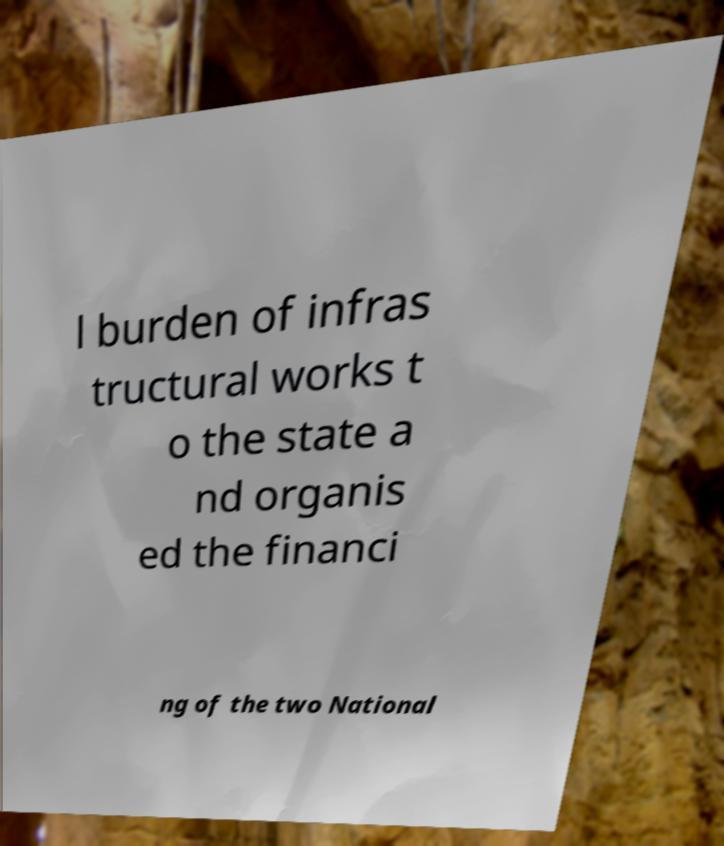Could you extract and type out the text from this image? l burden of infras tructural works t o the state a nd organis ed the financi ng of the two National 